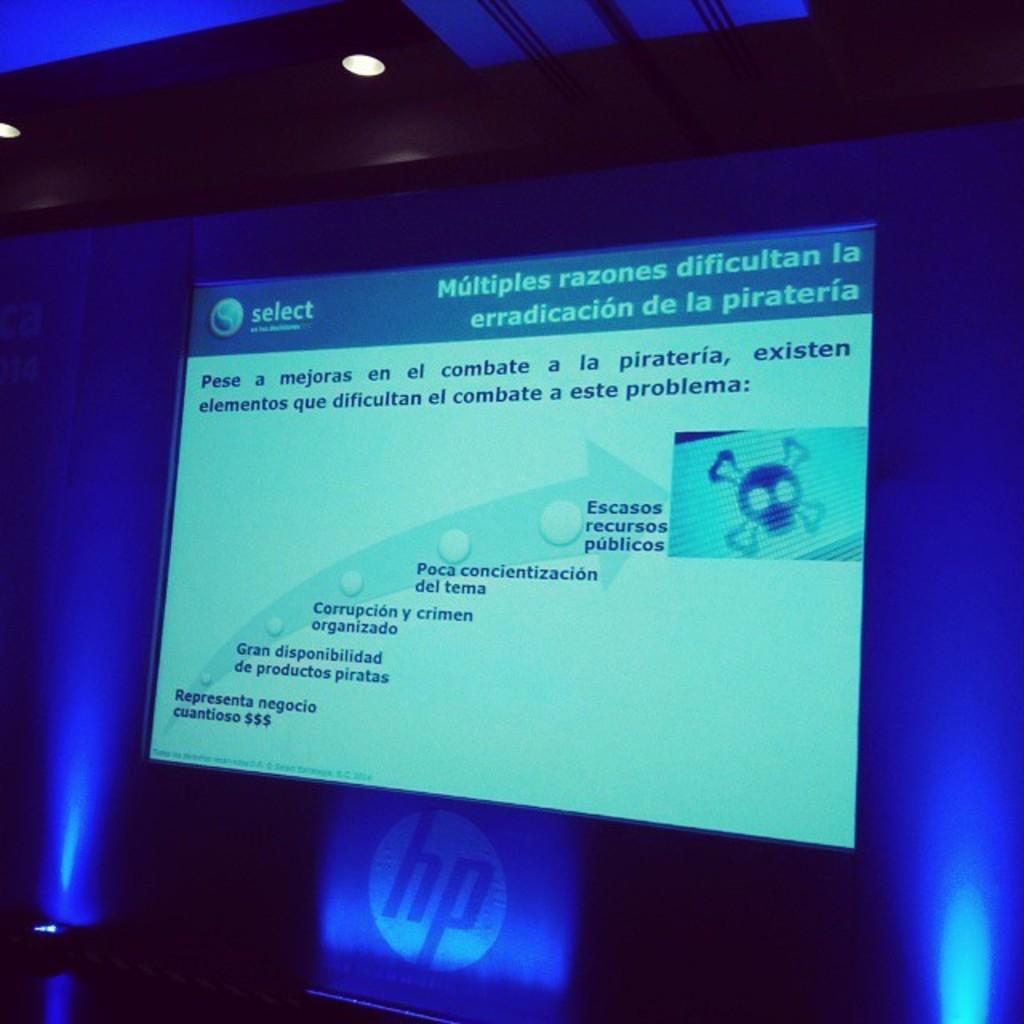What is the main subject in the image? There is a display in the image. What can be seen on the display? There is text present on the display. What type of lights are visible in the image? There are two blue color lights in the image. What type of bed is visible in the image? There is no bed present in the image; it features a display with text and two blue color lights. How does the lock on the bed function in the image? There is no bed or lock present in the image. 